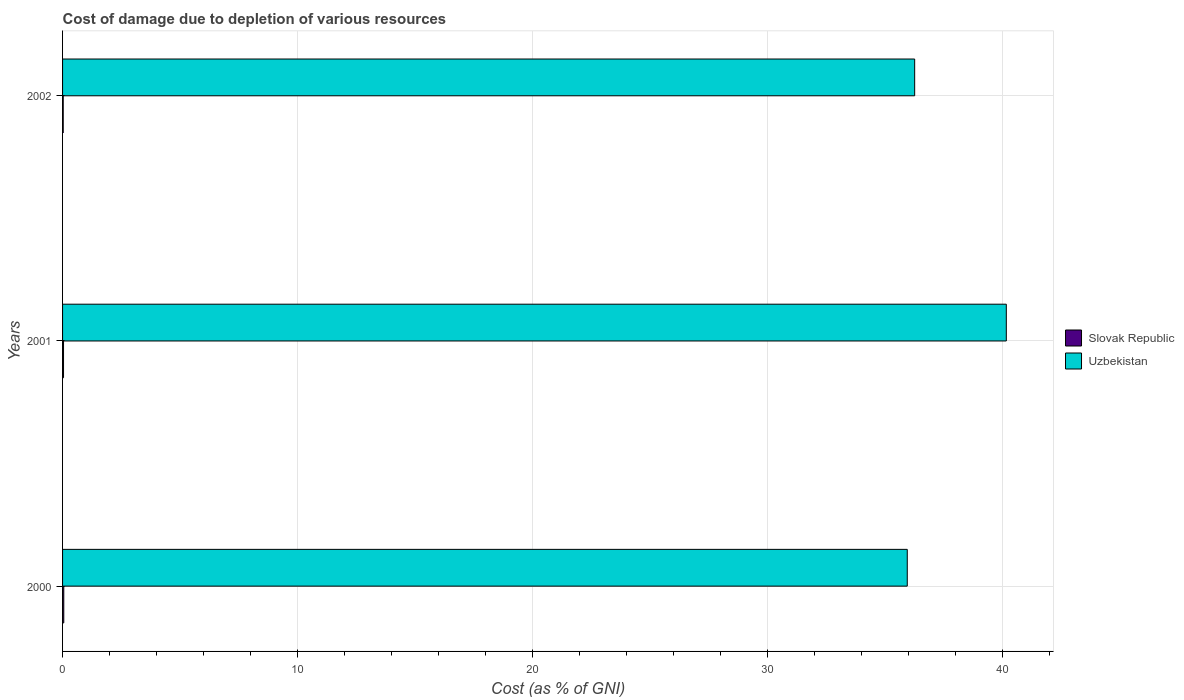How many different coloured bars are there?
Give a very brief answer. 2. Are the number of bars per tick equal to the number of legend labels?
Provide a succinct answer. Yes. Are the number of bars on each tick of the Y-axis equal?
Give a very brief answer. Yes. What is the cost of damage caused due to the depletion of various resources in Uzbekistan in 2000?
Keep it short and to the point. 35.95. Across all years, what is the maximum cost of damage caused due to the depletion of various resources in Uzbekistan?
Provide a short and direct response. 40.17. Across all years, what is the minimum cost of damage caused due to the depletion of various resources in Slovak Republic?
Your answer should be compact. 0.03. In which year was the cost of damage caused due to the depletion of various resources in Uzbekistan minimum?
Ensure brevity in your answer.  2000. What is the total cost of damage caused due to the depletion of various resources in Uzbekistan in the graph?
Offer a terse response. 112.38. What is the difference between the cost of damage caused due to the depletion of various resources in Slovak Republic in 2000 and that in 2001?
Your response must be concise. 0.01. What is the difference between the cost of damage caused due to the depletion of various resources in Slovak Republic in 2001 and the cost of damage caused due to the depletion of various resources in Uzbekistan in 2002?
Keep it short and to the point. -36.22. What is the average cost of damage caused due to the depletion of various resources in Slovak Republic per year?
Provide a succinct answer. 0.04. In the year 2000, what is the difference between the cost of damage caused due to the depletion of various resources in Slovak Republic and cost of damage caused due to the depletion of various resources in Uzbekistan?
Provide a succinct answer. -35.9. In how many years, is the cost of damage caused due to the depletion of various resources in Slovak Republic greater than 8 %?
Provide a short and direct response. 0. What is the ratio of the cost of damage caused due to the depletion of various resources in Uzbekistan in 2001 to that in 2002?
Your response must be concise. 1.11. Is the difference between the cost of damage caused due to the depletion of various resources in Slovak Republic in 2000 and 2001 greater than the difference between the cost of damage caused due to the depletion of various resources in Uzbekistan in 2000 and 2001?
Give a very brief answer. Yes. What is the difference between the highest and the second highest cost of damage caused due to the depletion of various resources in Slovak Republic?
Make the answer very short. 0.01. What is the difference between the highest and the lowest cost of damage caused due to the depletion of various resources in Uzbekistan?
Ensure brevity in your answer.  4.22. Is the sum of the cost of damage caused due to the depletion of various resources in Uzbekistan in 2000 and 2001 greater than the maximum cost of damage caused due to the depletion of various resources in Slovak Republic across all years?
Your response must be concise. Yes. What does the 2nd bar from the top in 2002 represents?
Your answer should be compact. Slovak Republic. What does the 2nd bar from the bottom in 2001 represents?
Your answer should be very brief. Uzbekistan. How many bars are there?
Your answer should be compact. 6. Are all the bars in the graph horizontal?
Provide a short and direct response. Yes. What is the difference between two consecutive major ticks on the X-axis?
Offer a very short reply. 10. How are the legend labels stacked?
Your answer should be very brief. Vertical. What is the title of the graph?
Your answer should be compact. Cost of damage due to depletion of various resources. Does "Upper middle income" appear as one of the legend labels in the graph?
Your answer should be very brief. No. What is the label or title of the X-axis?
Give a very brief answer. Cost (as % of GNI). What is the label or title of the Y-axis?
Keep it short and to the point. Years. What is the Cost (as % of GNI) in Slovak Republic in 2000?
Your answer should be compact. 0.05. What is the Cost (as % of GNI) in Uzbekistan in 2000?
Keep it short and to the point. 35.95. What is the Cost (as % of GNI) of Slovak Republic in 2001?
Your answer should be very brief. 0.04. What is the Cost (as % of GNI) of Uzbekistan in 2001?
Give a very brief answer. 40.17. What is the Cost (as % of GNI) in Slovak Republic in 2002?
Your response must be concise. 0.03. What is the Cost (as % of GNI) in Uzbekistan in 2002?
Your answer should be very brief. 36.27. Across all years, what is the maximum Cost (as % of GNI) in Slovak Republic?
Provide a succinct answer. 0.05. Across all years, what is the maximum Cost (as % of GNI) of Uzbekistan?
Offer a very short reply. 40.17. Across all years, what is the minimum Cost (as % of GNI) of Slovak Republic?
Your answer should be very brief. 0.03. Across all years, what is the minimum Cost (as % of GNI) of Uzbekistan?
Your answer should be very brief. 35.95. What is the total Cost (as % of GNI) in Slovak Republic in the graph?
Ensure brevity in your answer.  0.12. What is the total Cost (as % of GNI) in Uzbekistan in the graph?
Give a very brief answer. 112.38. What is the difference between the Cost (as % of GNI) in Slovak Republic in 2000 and that in 2001?
Give a very brief answer. 0.01. What is the difference between the Cost (as % of GNI) of Uzbekistan in 2000 and that in 2001?
Keep it short and to the point. -4.22. What is the difference between the Cost (as % of GNI) in Slovak Republic in 2000 and that in 2002?
Keep it short and to the point. 0.02. What is the difference between the Cost (as % of GNI) of Uzbekistan in 2000 and that in 2002?
Provide a succinct answer. -0.32. What is the difference between the Cost (as % of GNI) in Slovak Republic in 2001 and that in 2002?
Your response must be concise. 0.01. What is the difference between the Cost (as % of GNI) of Uzbekistan in 2001 and that in 2002?
Make the answer very short. 3.9. What is the difference between the Cost (as % of GNI) of Slovak Republic in 2000 and the Cost (as % of GNI) of Uzbekistan in 2001?
Offer a very short reply. -40.11. What is the difference between the Cost (as % of GNI) of Slovak Republic in 2000 and the Cost (as % of GNI) of Uzbekistan in 2002?
Offer a terse response. -36.21. What is the difference between the Cost (as % of GNI) in Slovak Republic in 2001 and the Cost (as % of GNI) in Uzbekistan in 2002?
Provide a short and direct response. -36.22. What is the average Cost (as % of GNI) in Slovak Republic per year?
Provide a short and direct response. 0.04. What is the average Cost (as % of GNI) of Uzbekistan per year?
Give a very brief answer. 37.46. In the year 2000, what is the difference between the Cost (as % of GNI) of Slovak Republic and Cost (as % of GNI) of Uzbekistan?
Provide a short and direct response. -35.9. In the year 2001, what is the difference between the Cost (as % of GNI) in Slovak Republic and Cost (as % of GNI) in Uzbekistan?
Offer a terse response. -40.12. In the year 2002, what is the difference between the Cost (as % of GNI) in Slovak Republic and Cost (as % of GNI) in Uzbekistan?
Provide a succinct answer. -36.24. What is the ratio of the Cost (as % of GNI) of Slovak Republic in 2000 to that in 2001?
Make the answer very short. 1.26. What is the ratio of the Cost (as % of GNI) of Uzbekistan in 2000 to that in 2001?
Offer a very short reply. 0.9. What is the ratio of the Cost (as % of GNI) of Slovak Republic in 2000 to that in 2002?
Offer a terse response. 1.86. What is the ratio of the Cost (as % of GNI) in Slovak Republic in 2001 to that in 2002?
Offer a very short reply. 1.48. What is the ratio of the Cost (as % of GNI) of Uzbekistan in 2001 to that in 2002?
Provide a short and direct response. 1.11. What is the difference between the highest and the second highest Cost (as % of GNI) in Slovak Republic?
Provide a short and direct response. 0.01. What is the difference between the highest and the second highest Cost (as % of GNI) of Uzbekistan?
Keep it short and to the point. 3.9. What is the difference between the highest and the lowest Cost (as % of GNI) of Slovak Republic?
Keep it short and to the point. 0.02. What is the difference between the highest and the lowest Cost (as % of GNI) in Uzbekistan?
Provide a succinct answer. 4.22. 